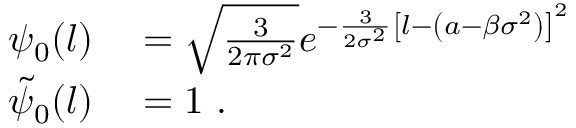Convert formula to latex. <formula><loc_0><loc_0><loc_500><loc_500>\begin{array} { r l } { \psi _ { 0 } ( l ) } & = \sqrt { \frac { 3 } { 2 \pi \sigma ^ { 2 } } } e ^ { - \frac { 3 } { 2 \sigma ^ { 2 } } \left [ l - \left ( a - \beta \sigma ^ { 2 } \right ) \right ] ^ { 2 } } } \\ { \tilde { \psi } _ { 0 } ( l ) } & = 1 \ . } \end{array}</formula> 